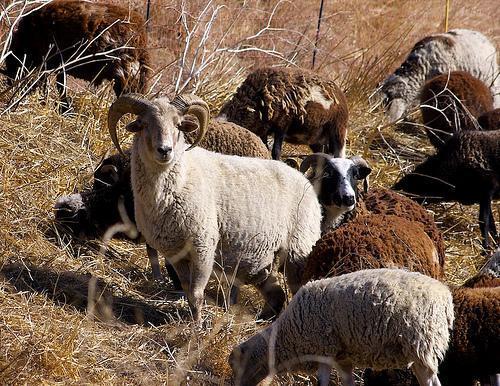How many goats are looking at camera?
Give a very brief answer. 1. 